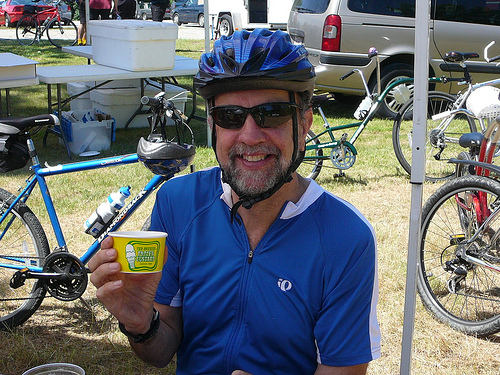Can you tell me what the weather might be like in this photo? Based on the bright lighting and the clear skies visible in the background, it appears to be a sunny and pleasant day, conducive for outdoor activities like cycling. 